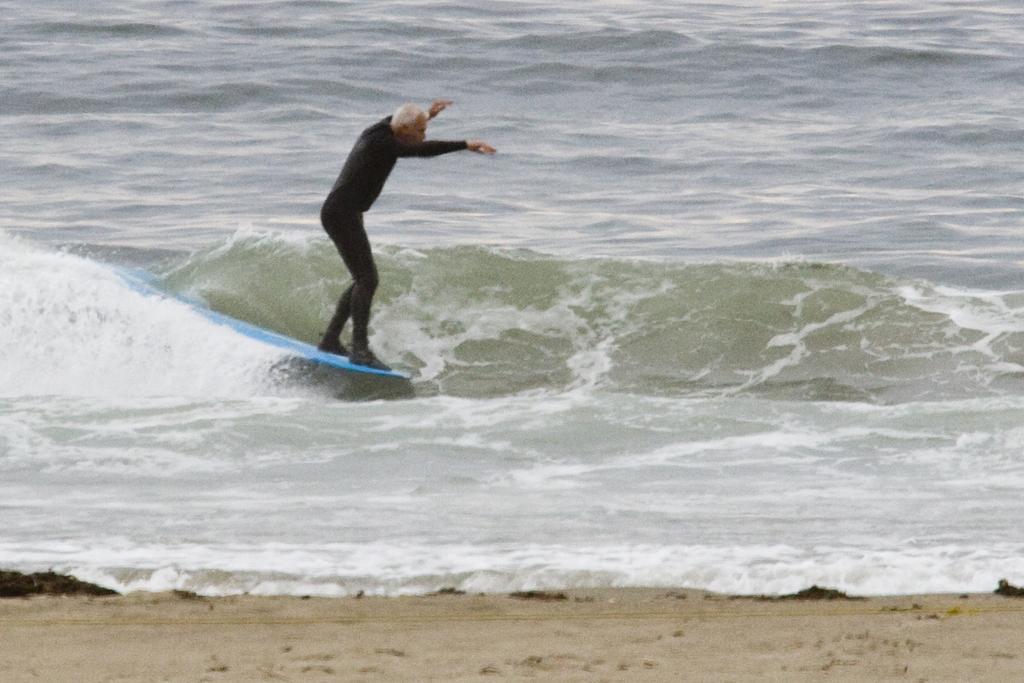Can you describe this image briefly? In the foreground of this image, there is a man surfing on the water. At the bottom, there is the sand. 